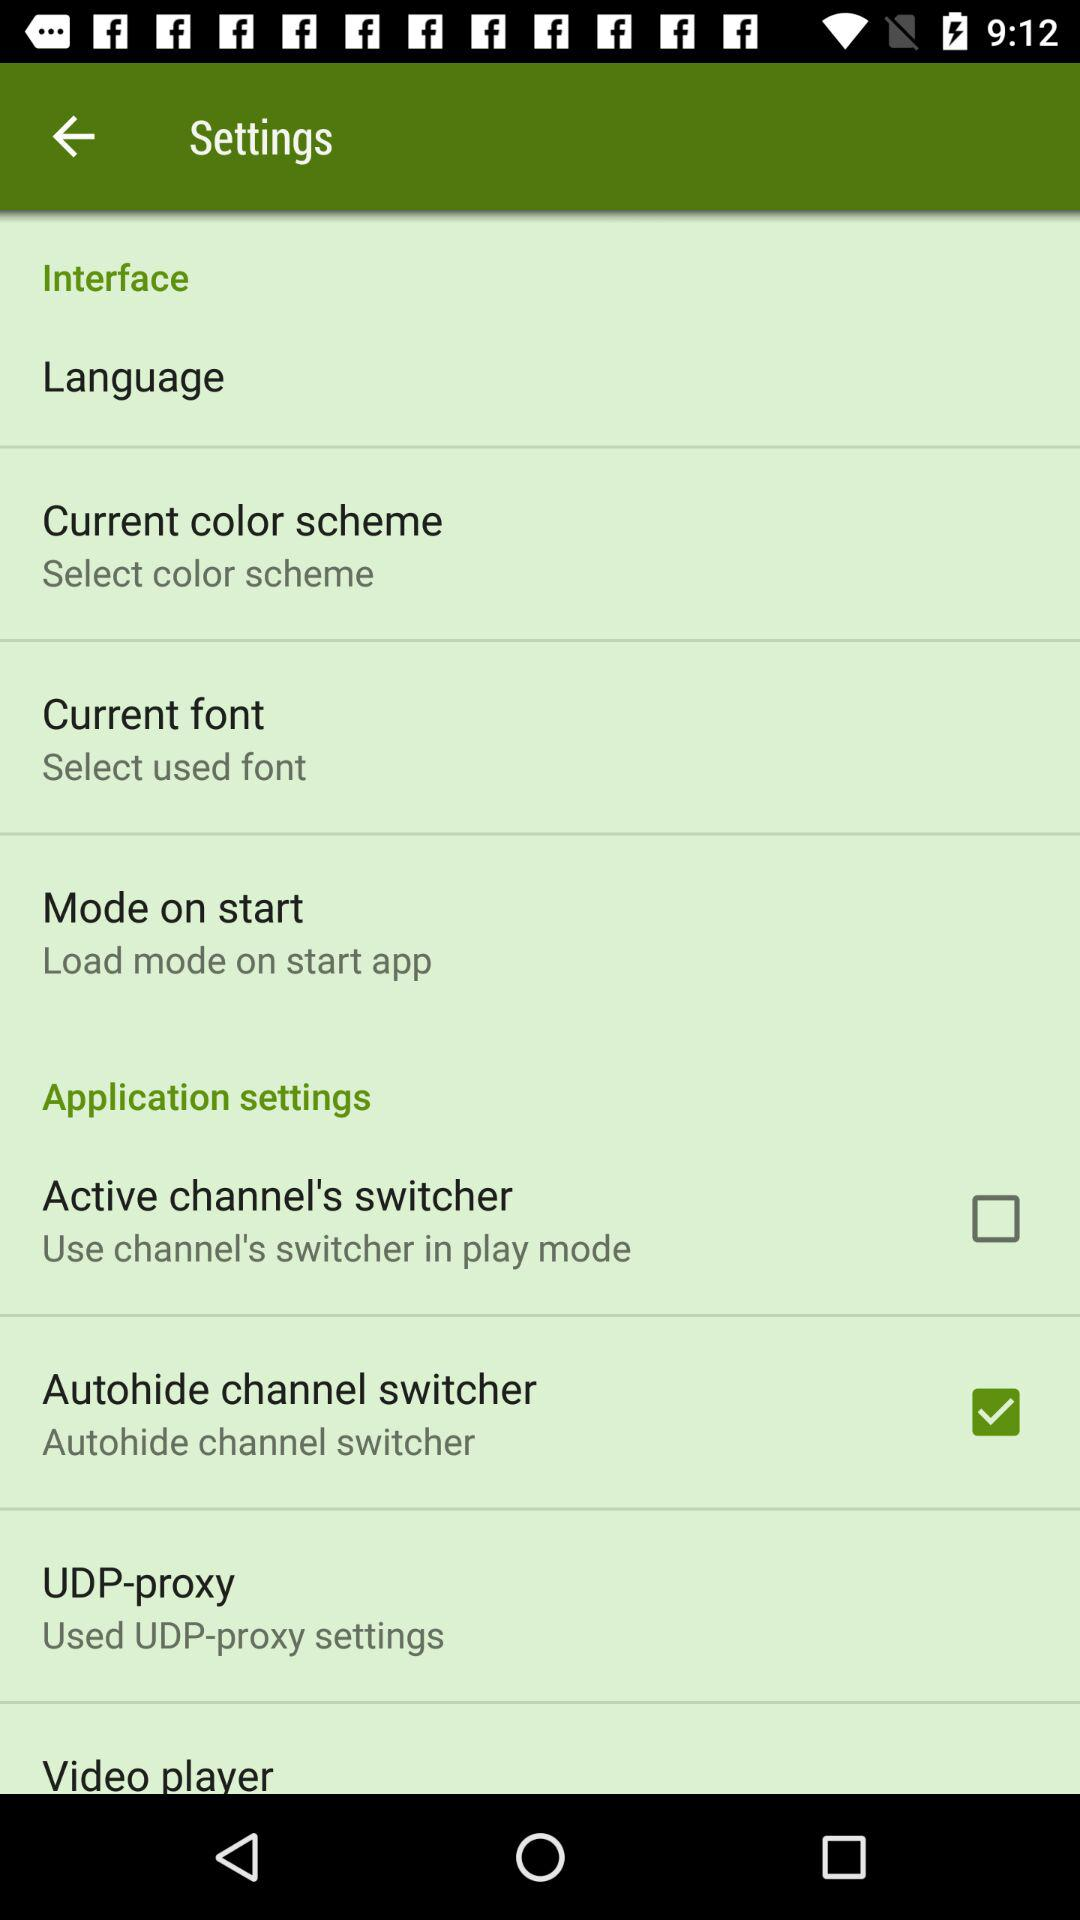What is the status of "Active channel's switcher"? The status is "off". 